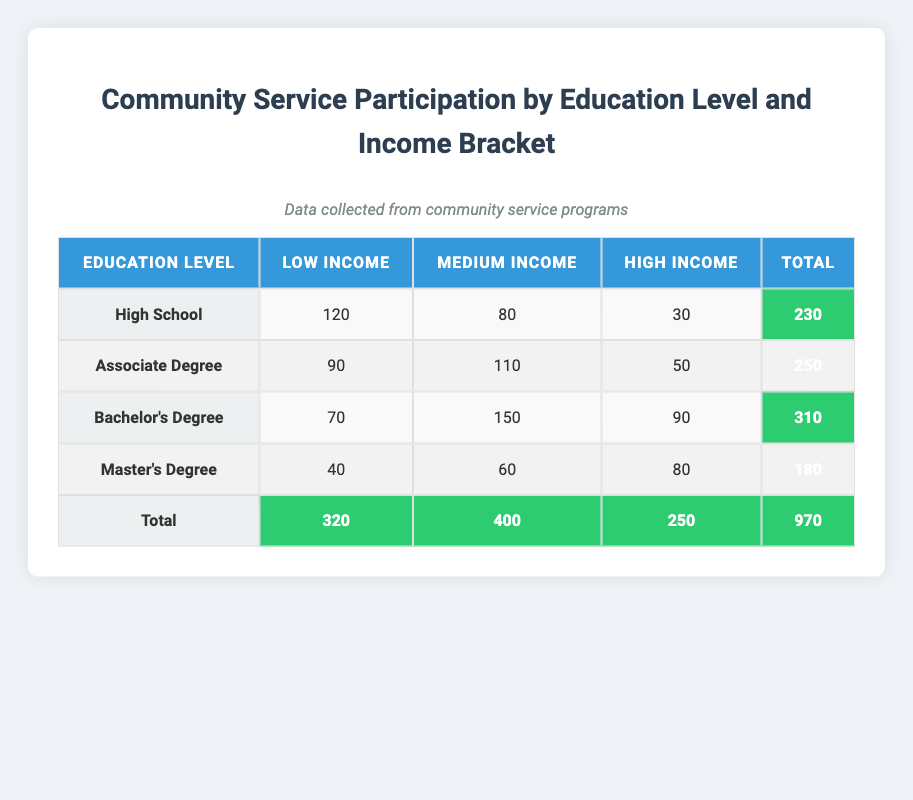What is the total number of participants with a Master's Degree? From the table, under the "Master's Degree" row, I find the total participants listed as 180. I simply read the total from the last column corresponding to this education level.
Answer: 180 How many participants from low-income backgrounds have a Bachelor's Degree? The table shows that under the "Bachelor's Degree" row, the number of participants with a low income is listed as 70. This is retrieved directly from that specific cell.
Answer: 70 Which education level has the highest number of participants in the medium income bracket? Looking under the medium income column, "Bachelor's Degree" has 150 participants, which is greater than the other education levels: High School (80), Associate Degree (110), and Master's Degree (60). Thus, Bachelor's Degree has the highest participation.
Answer: Bachelor's Degree What is the difference in participation between low-income and high-income for Associate Degrees? Under the "Associate Degree" row, there are 90 participants for low income and 50 for high income. To find the difference, I subtract 50 from 90, which is 40.
Answer: 40 Is the total number of participants in community service greater than 1000? The total number of participants across all education levels and income brackets is 970 as indicated at the bottom of the table. Since 970 is less than 1000, the statement is false.
Answer: No How many total participants are there from low-income backgrounds? To find this, I sum the low-income participants: 120 (High School) + 90 (Associate Degree) + 70 (Bachelor's Degree) + 40 (Master's Degree) = 320. This gives the total number of low-income participants.
Answer: 320 What is the average number of participants across all education levels for the high-income bracket? I first retrieve the high-income participation numbers: 30 (High School), 50 (Associate Degree), 90 (Bachelor's Degree), and 80 (Master's Degree). Summing these gives 30 + 50 + 90 + 80 = 250. There are 4 education levels, so the average is 250 / 4 = 62.5.
Answer: 62.5 How many more participants are there from the medium-income bracket compared to the low-income bracket in total? First, I find the total number of participants in the medium-income bracket: 80 (High School) + 110 (Associate Degree) + 150 (Bachelor's Degree) + 60 (Master's Degree) = 400. For low-income: 120 + 90 + 70 + 40 = 320. Now, subtracting 400 - 320 gives us 80 more participants in the medium-income bracket.
Answer: 80 